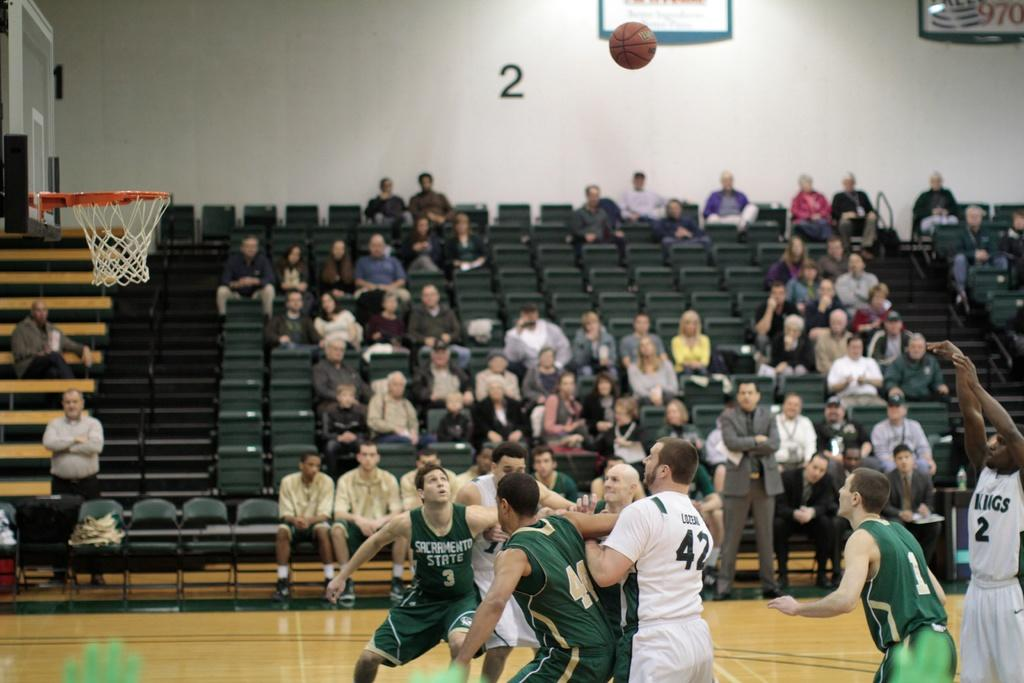Provide a one-sentence caption for the provided image. Man in a white number 2 jersey shooting a shot. 